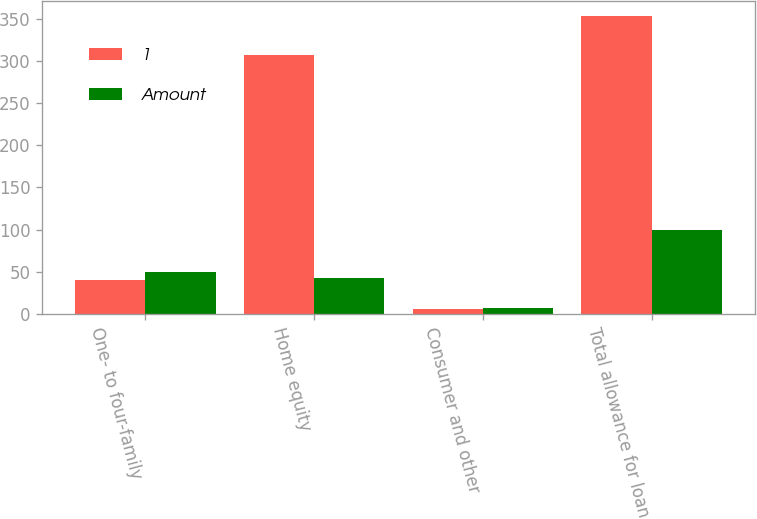<chart> <loc_0><loc_0><loc_500><loc_500><stacked_bar_chart><ecel><fcel>One- to four-family<fcel>Home equity<fcel>Consumer and other<fcel>Total allowance for loan<nl><fcel>1<fcel>40<fcel>307<fcel>6<fcel>353<nl><fcel>Amount<fcel>50.3<fcel>42.8<fcel>6.9<fcel>100<nl></chart> 